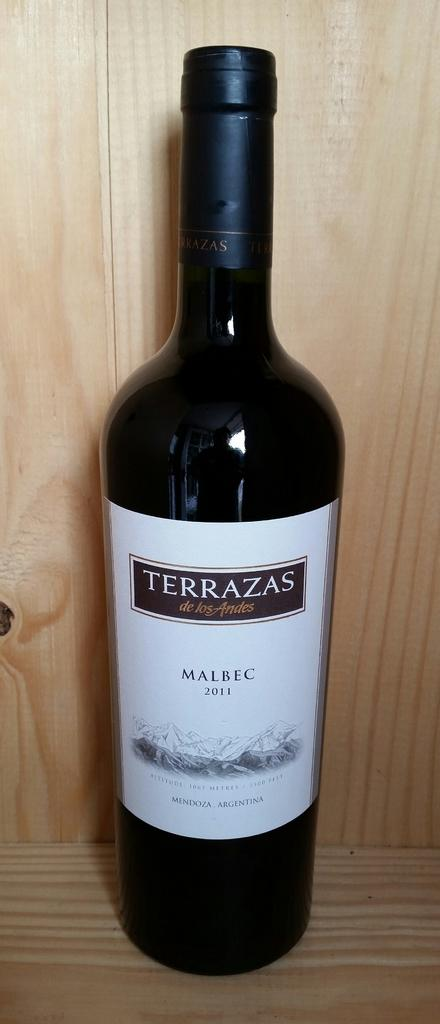<image>
Create a compact narrative representing the image presented. A 2011 Argentinian wine is on a wooden shelf. 